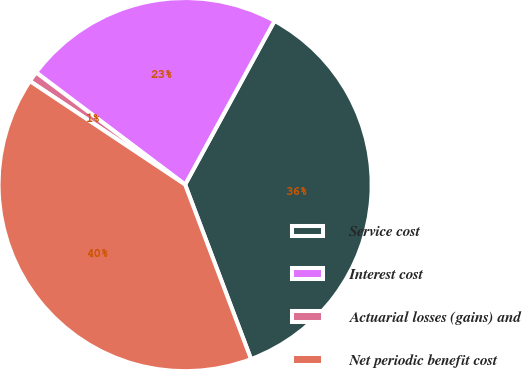Convert chart. <chart><loc_0><loc_0><loc_500><loc_500><pie_chart><fcel>Service cost<fcel>Interest cost<fcel>Actuarial losses (gains) and<fcel>Net periodic benefit cost<nl><fcel>36.3%<fcel>22.69%<fcel>0.91%<fcel>40.11%<nl></chart> 